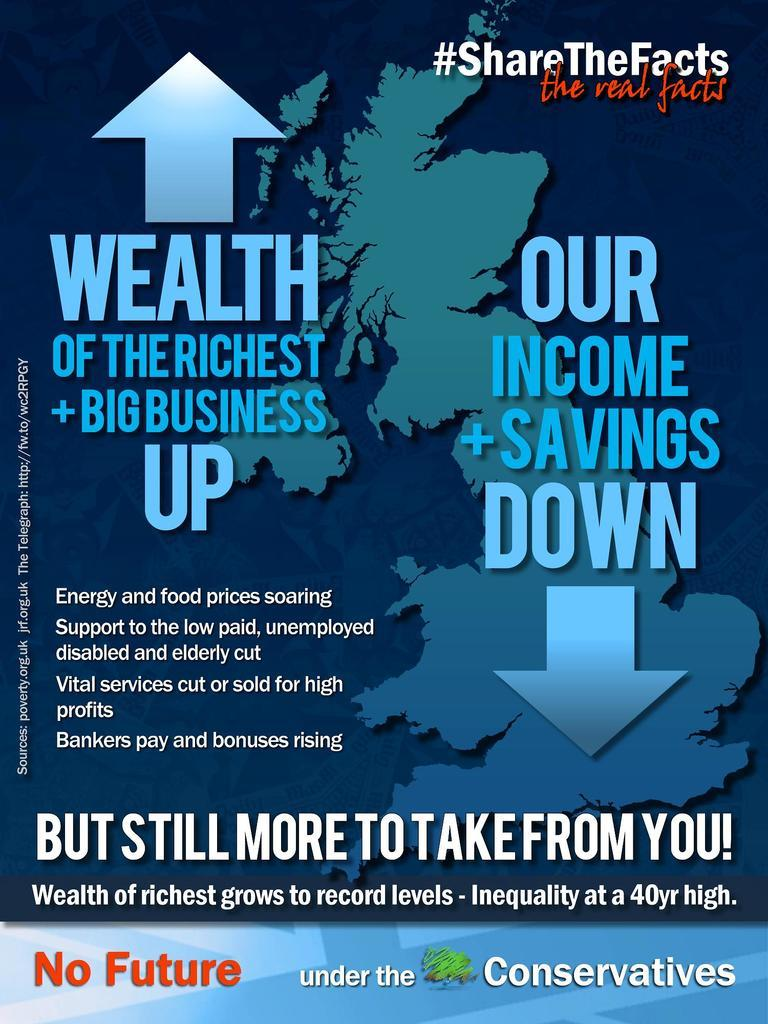<image>
Render a clear and concise summary of the photo. out about Wealth of the Richest Big Business in this reading material. 